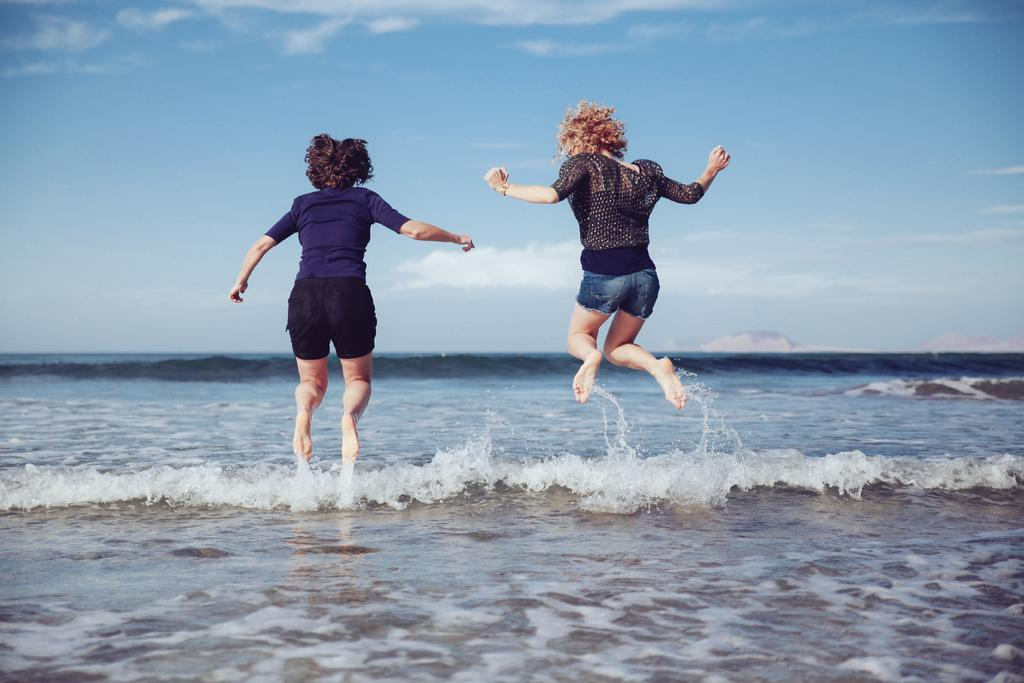How many people are in the image? There are two girls in the image. What are the girls doing in the image? The girls are jumping in the image. What is the nature of their activity? There is water involved in their activity. What can be seen in the background of the image? The sky is visible in the image. What is the color of the sky? The color of the sky is blue. What time of day is it in the image, as indicated by the presence of the porter? There is no porter present in the image, and therefore no indication of the time of day. 